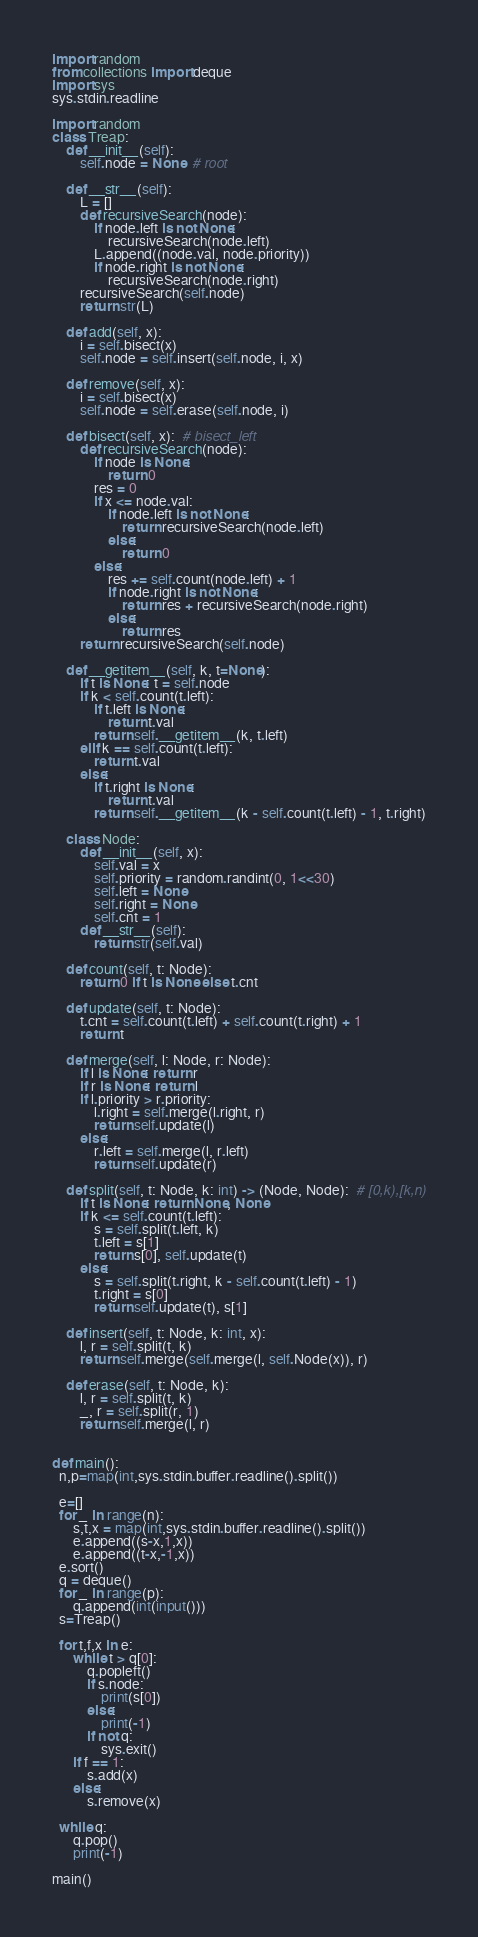Convert code to text. <code><loc_0><loc_0><loc_500><loc_500><_Python_>import random
from collections import deque
import sys
sys.stdin.readline

import random
class Treap:
    def __init__(self):
        self.node = None  # root

    def __str__(self):
        L = []
        def recursiveSearch(node):
            if node.left is not None:
                recursiveSearch(node.left)
            L.append((node.val, node.priority))
            if node.right is not None:
                recursiveSearch(node.right)
        recursiveSearch(self.node)
        return str(L)

    def add(self, x):
        i = self.bisect(x)
        self.node = self.insert(self.node, i, x)

    def remove(self, x):
        i = self.bisect(x)
        self.node = self.erase(self.node, i)

    def bisect(self, x):  # bisect_left
        def recursiveSearch(node):
            if node is None:
                return 0
            res = 0
            if x <= node.val:
                if node.left is not None:
                    return recursiveSearch(node.left)
                else:
                    return 0
            else:
                res += self.count(node.left) + 1
                if node.right is not None:
                    return res + recursiveSearch(node.right)
                else:
                    return res
        return recursiveSearch(self.node)

    def __getitem__(self, k, t=None):
        if t is None: t = self.node
        if k < self.count(t.left):
            if t.left is None:
                return t.val
            return self.__getitem__(k, t.left)
        elif k == self.count(t.left):
            return t.val
        else:
            if t.right is None:
                return t.val
            return self.__getitem__(k - self.count(t.left) - 1, t.right)

    class Node:
        def __init__(self, x):
            self.val = x
            self.priority = random.randint(0, 1<<30)
            self.left = None
            self.right = None
            self.cnt = 1
        def __str__(self):
            return str(self.val)

    def count(self, t: Node):
        return 0 if t is None else t.cnt

    def update(self, t: Node):
        t.cnt = self.count(t.left) + self.count(t.right) + 1
        return t

    def merge(self, l: Node, r: Node):
        if l is None: return r
        if r is None: return l
        if l.priority > r.priority:
            l.right = self.merge(l.right, r)
            return self.update(l)
        else:
            r.left = self.merge(l, r.left)
            return self.update(r)

    def split(self, t: Node, k: int) -> (Node, Node):  # [0,k),[k,n)
        if t is None: return None, None
        if k <= self.count(t.left):
            s = self.split(t.left, k)
            t.left = s[1]
            return s[0], self.update(t)
        else:
            s = self.split(t.right, k - self.count(t.left) - 1)
            t.right = s[0]
            return self.update(t), s[1]

    def insert(self, t: Node, k: int, x):
        l, r = self.split(t, k)
        return self.merge(self.merge(l, self.Node(x)), r)

    def erase(self, t: Node, k):
        l, r = self.split(t, k)
        _, r = self.split(r, 1)
        return self.merge(l, r)

    
def main():
  n,p=map(int,sys.stdin.buffer.readline().split())

  e=[]
  for _ in range(n):
      s,t,x = map(int,sys.stdin.buffer.readline().split())
      e.append((s-x,1,x))
      e.append((t-x,-1,x))
  e.sort()
  q = deque()
  for _ in range(p):
      q.append(int(input()))
  s=Treap()

  for t,f,x in e:
      while t > q[0]:
          q.popleft()
          if s.node:
              print(s[0])
          else:
              print(-1)
          if not q:
              sys.exit()
      if f == 1:
          s.add(x)
      else:
          s.remove(x)

  while q:
      q.pop()
      print(-1)

main()</code> 